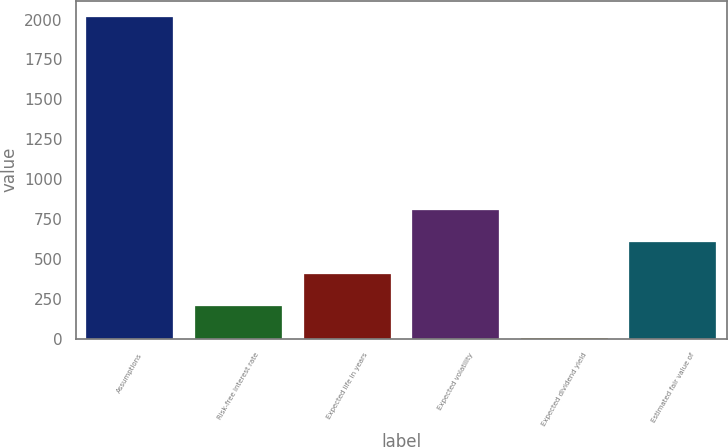<chart> <loc_0><loc_0><loc_500><loc_500><bar_chart><fcel>Assumptions<fcel>Risk-free interest rate<fcel>Expected life in years<fcel>Expected volatility<fcel>Expected dividend yield<fcel>Estimated fair value of<nl><fcel>2016<fcel>202.82<fcel>404.28<fcel>807.2<fcel>1.36<fcel>605.74<nl></chart> 